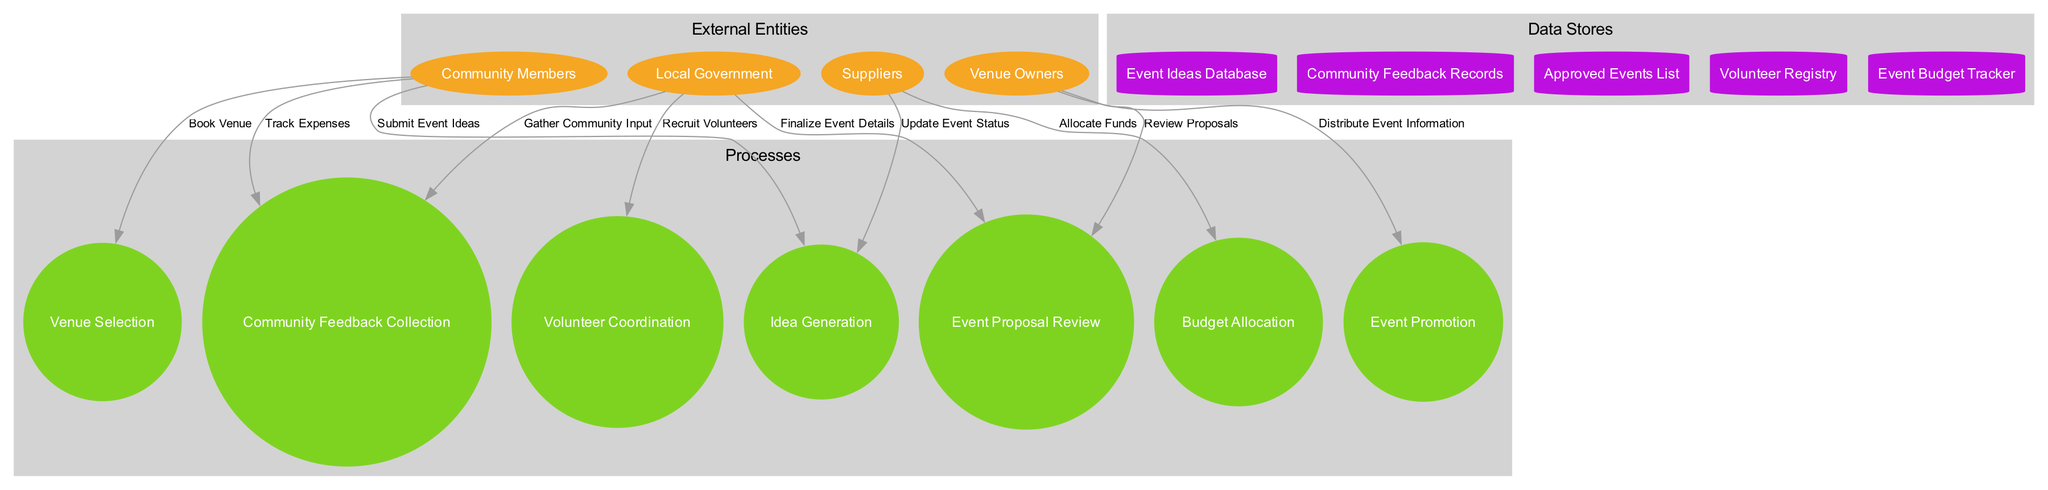What are the external entities in the diagram? The external entities are indicated in the left section of the diagram; they consist of Community Members, Local Government, Venue Owners, and Suppliers, all of which are represented as ellipses.
Answer: Community Members, Local Government, Venue Owners, Suppliers How many processes are there in the community event planning process? The processes can be counted from the circular nodes in the diagram, which include Idea Generation, Community Feedback Collection, Event Proposal Review, Budget Allocation, Venue Selection, Volunteer Coordination, and Event Promotion. A total of seven processes are present.
Answer: 7 Which process receives feedback from the community? By tracing the flow in the diagram, the Community Feedback Collection process is specifically designated to gather input from the community, depicting the direction of data flow.
Answer: Community Feedback Collection What data store holds approved events? The data store specifically labeled as Approved Events List in the diagram is responsible for holding information regarding events that have received approval. It is represented as a cylinder.
Answer: Approved Events List How many data flows are depicted in the diagram? The data flows can be counted as the connections labeled between external entities, processes, and data stores. In total, there are ten data flows represented in the diagram.
Answer: 10 Which external entity provides event ideas? By analyzing the connections in the diagram, it is clear that Community Members submit event ideas, making them the main source for generating new ideas for events.
Answer: Community Members Explain the relationship between budget allocation and volunteer coordination. The Budget Allocation process provides necessary funding to the Volunteer Coordination process, establishing a flow of information and directing that the coordinated volunteers are funded for their efforts in event execution. This relation is represented as a data flow labeled as Allocate Funds.
Answer: Funding flow between Budget Allocation and Volunteer Coordination What is the first step in the event planning process? The diagram indicates that the first process in the event planning workflow is Idea Generation, which is the initiation point where community event ideas are conceived.
Answer: Idea Generation 